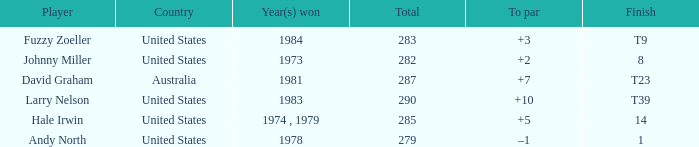Which player finished at +10? Larry Nelson. Help me parse the entirety of this table. {'header': ['Player', 'Country', 'Year(s) won', 'Total', 'To par', 'Finish'], 'rows': [['Fuzzy Zoeller', 'United States', '1984', '283', '+3', 'T9'], ['Johnny Miller', 'United States', '1973', '282', '+2', '8'], ['David Graham', 'Australia', '1981', '287', '+7', 'T23'], ['Larry Nelson', 'United States', '1983', '290', '+10', 'T39'], ['Hale Irwin', 'United States', '1974 , 1979', '285', '+5', '14'], ['Andy North', 'United States', '1978', '279', '–1', '1']]} 